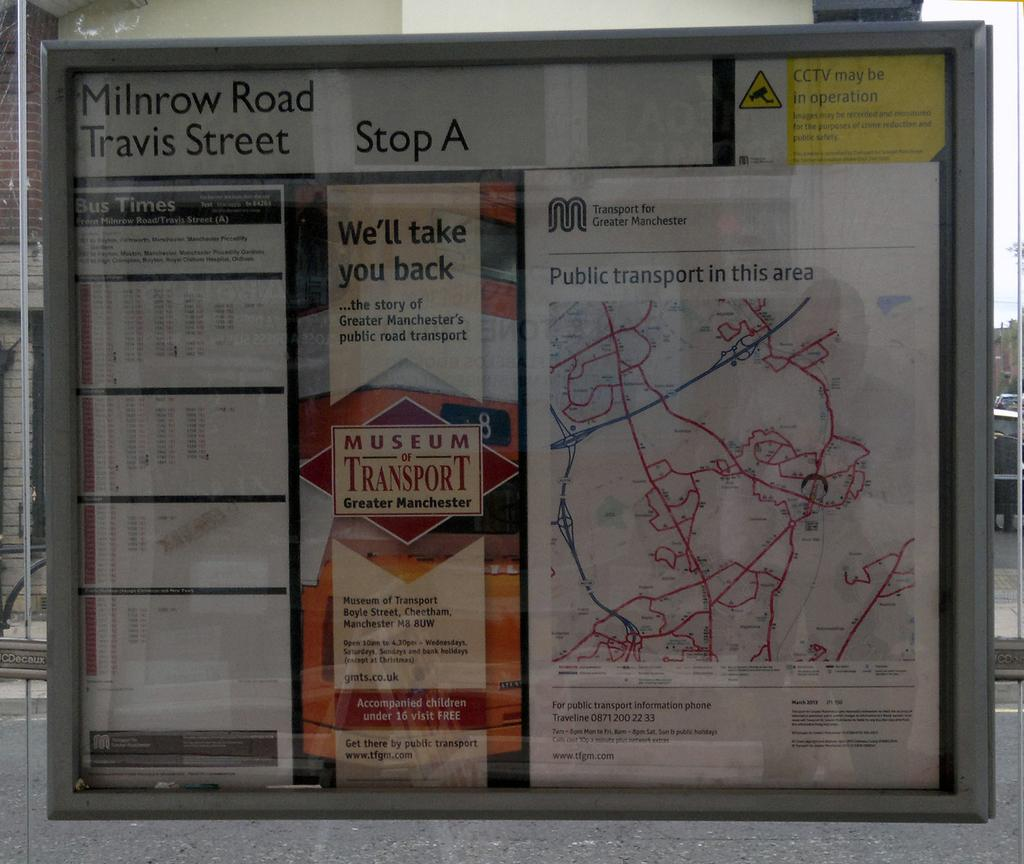Provide a one-sentence caption for the provided image. Milnrow Road and Travis Street are at Stop A on the map of Greater Manchester. 